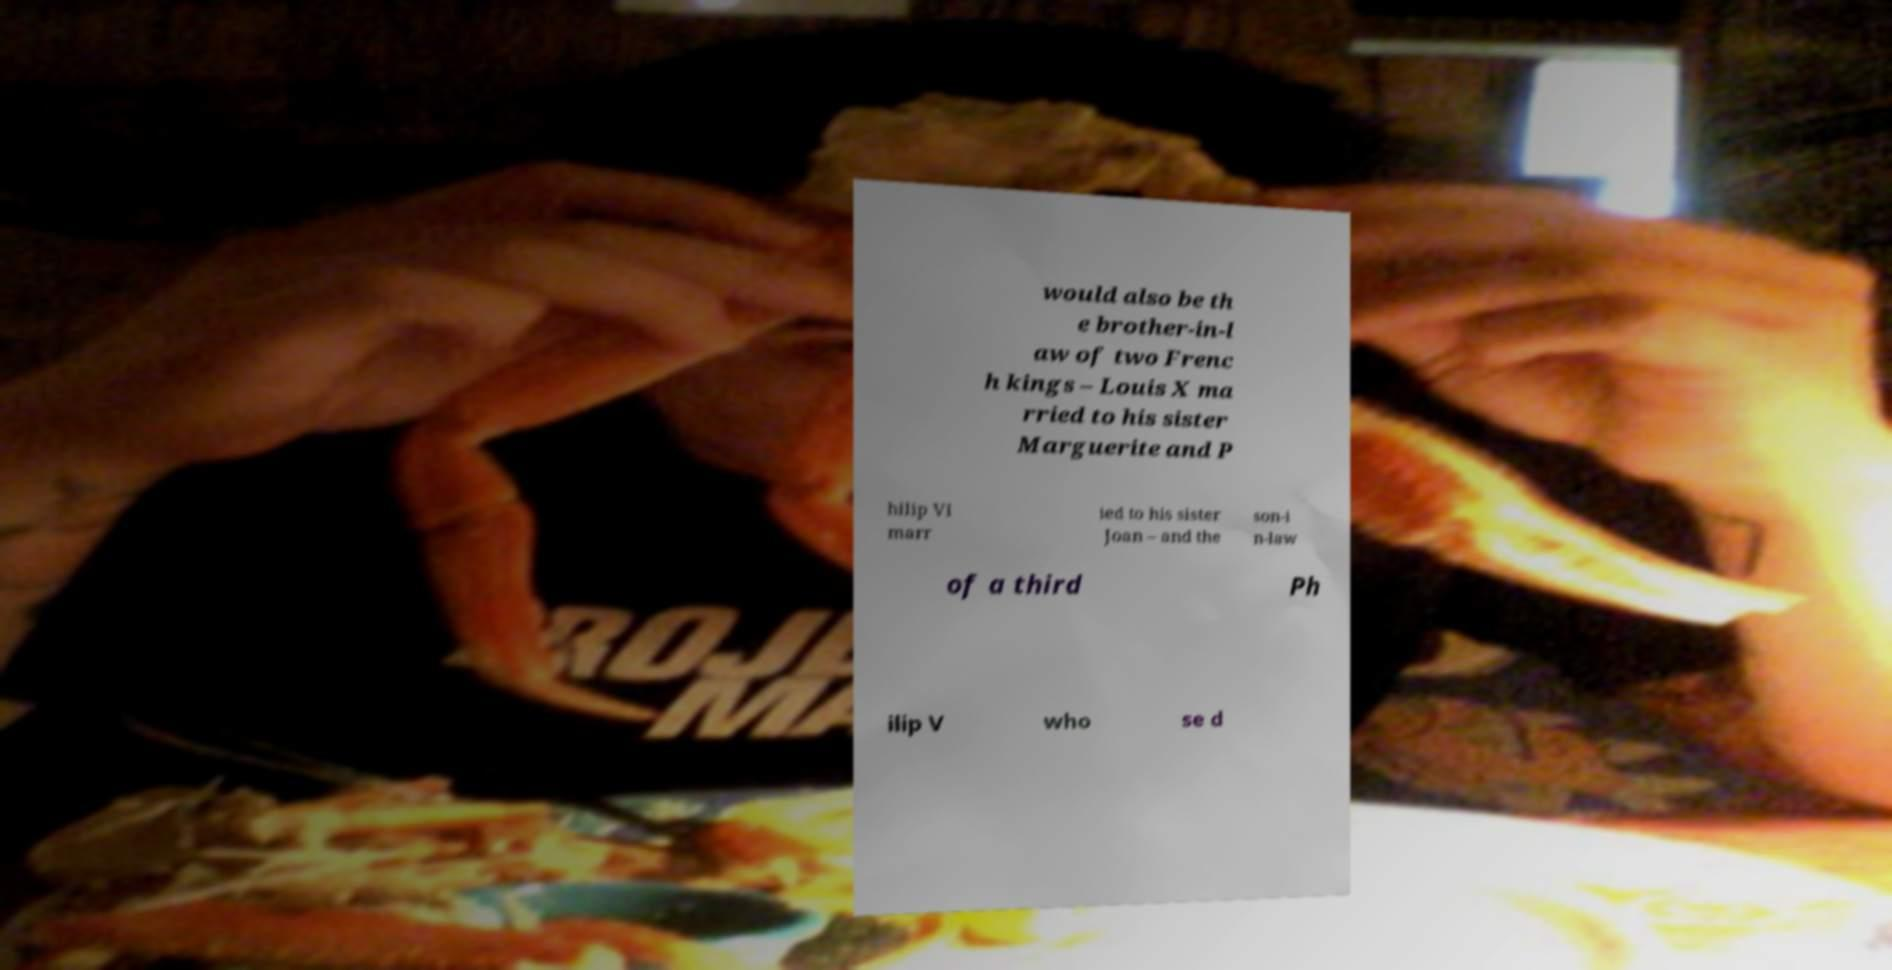Can you read and provide the text displayed in the image?This photo seems to have some interesting text. Can you extract and type it out for me? would also be th e brother-in-l aw of two Frenc h kings – Louis X ma rried to his sister Marguerite and P hilip VI marr ied to his sister Joan – and the son-i n-law of a third Ph ilip V who se d 